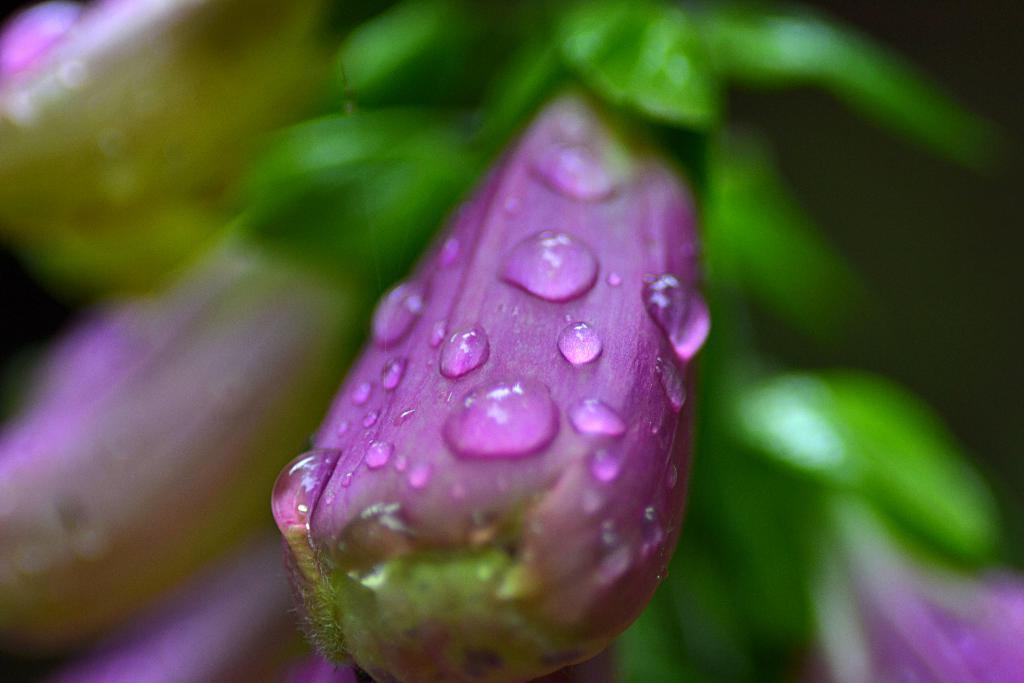Describe this image in one or two sentences. There are water drops on the violet color flower of a plant. Which is having violet color flowers. And the background is blurred. 